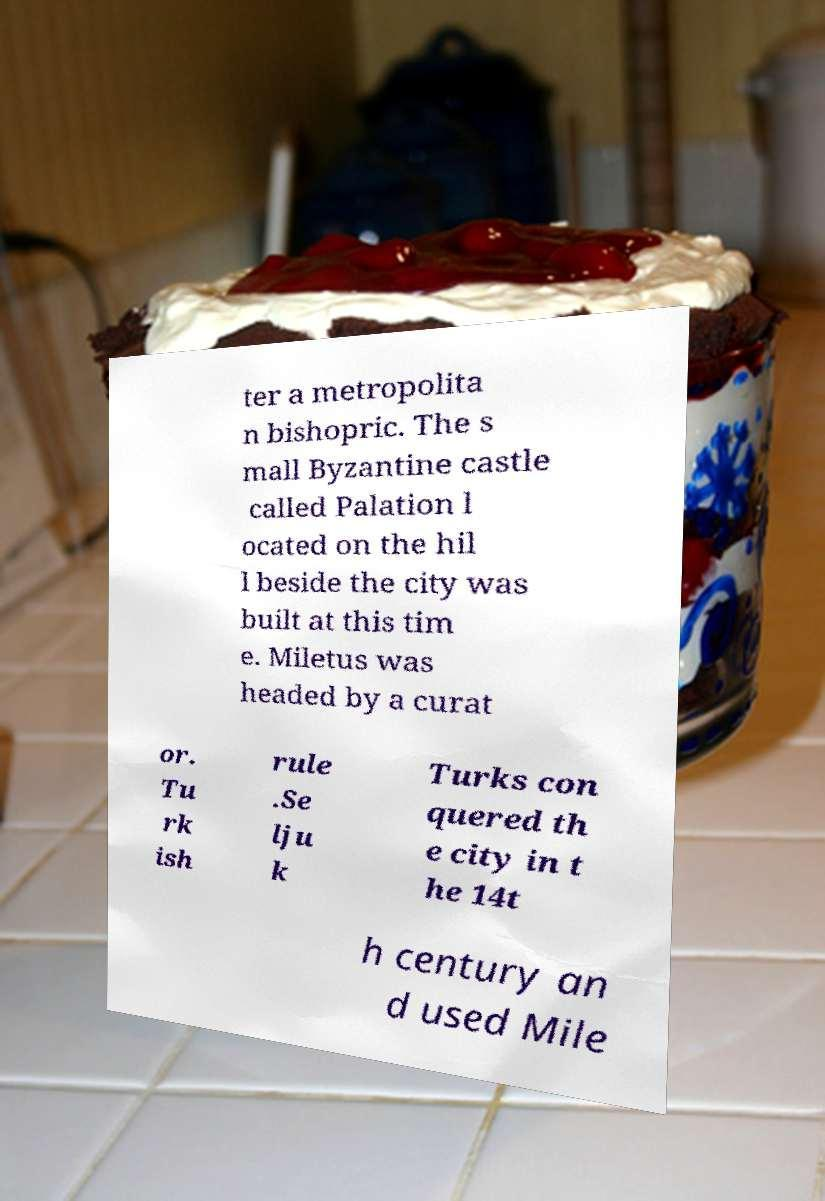Please identify and transcribe the text found in this image. ter a metropolita n bishopric. The s mall Byzantine castle called Palation l ocated on the hil l beside the city was built at this tim e. Miletus was headed by a curat or. Tu rk ish rule .Se lju k Turks con quered th e city in t he 14t h century an d used Mile 